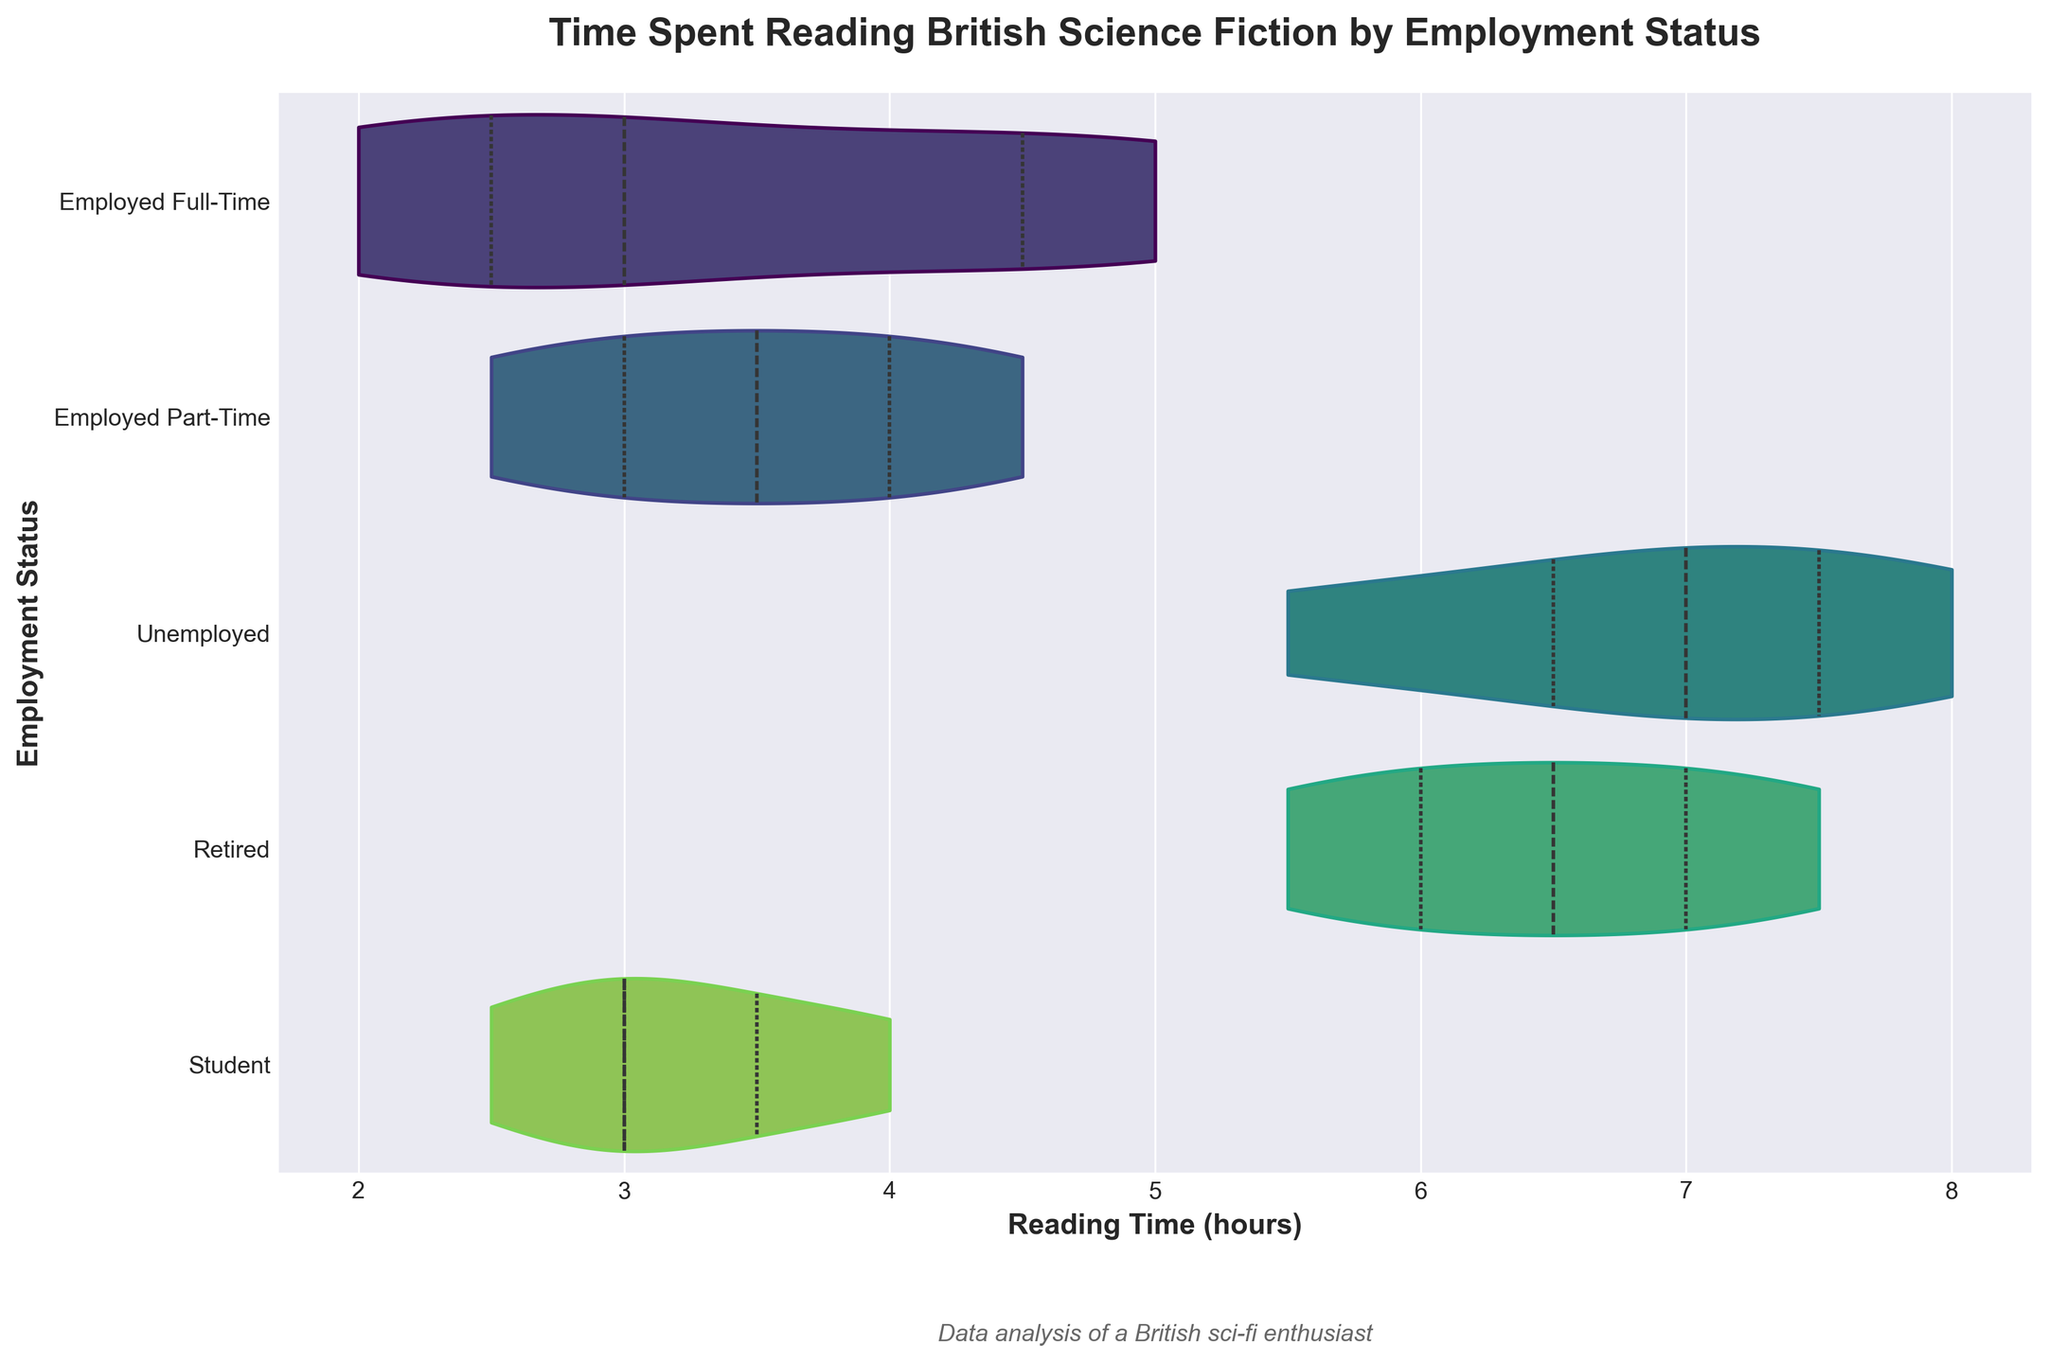How does the reading time for retired individuals compare with that of employed full-time individuals? From the violin chart, the reading time for retired individuals ranges mostly between 5.5 and 7.5 hours, which is clearly higher than that of full-time employed individuals, whose reading time hovers between 2 and 5 hours.
Answer: Retired individuals read more What is the median reading time for students based on the chart? The violin plot for students shows the thickest part (interquartile range) around 3 hours, and the median, represented by the thin line within this range, appears to be slightly above 3.
Answer: Slightly above 3 hours Which employment status group shows the widest range of reading times? By inspecting the width and spread of the violins, unemployed individuals show the widest range from about 5.5 to 8 hours.
Answer: Unemployed individuals Are there any employment groups with overlapping reading time ranges? The violin ranges for employed part-time and students overlap in the region between 2.5 and 4.5 hours.
Answer: Yes, part-time workers and students What is the overall shape and distribution of the reading times for full-time employed individuals? The violin plot for full-time employed individuals is relatively narrow and symmetric, concentrated mostly between 2 and 5 hours, forming a moderately peaked distribution.
Answer: Narrow and symmetric, peaked around 2-5 hours What does the inner “quartile” line represent in these violin plots? The thin line inside the violins denotes the interquartile range—the middle 50% of the data, which provides insight into data spread and central tendency without outliers’ influence.
Answer: Interquartile range How does the distribution of reading times compare between part-time and full-time employed individuals? Part-time employed individuals have a more spread out distribution, ranging from 2.5 to 4.5 hours, while full-time employed individuals are more concentrated between 2 and 5 hours, showing slightly less variability.
Answer: Part-time is more spread out Which group has the highest median reading time? The violin plot for unemployed individuals shows the highest median, with the median line closer to the top edge of the violin (around 7 hours).
Answer: Unemployed individuals 